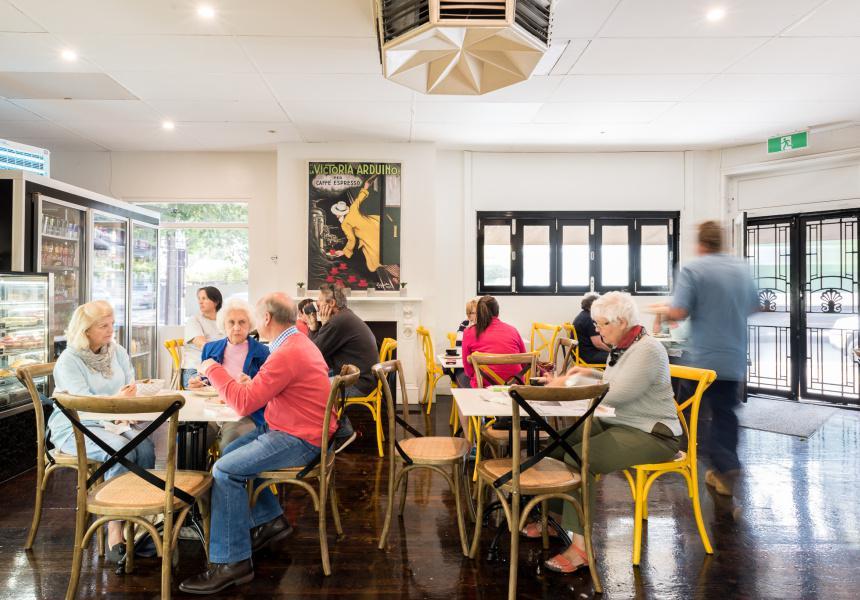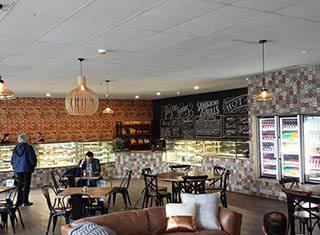The first image is the image on the left, the second image is the image on the right. Evaluate the accuracy of this statement regarding the images: "We can see the outdoor seats to the restaurant.". Is it true? Answer yes or no. No. 